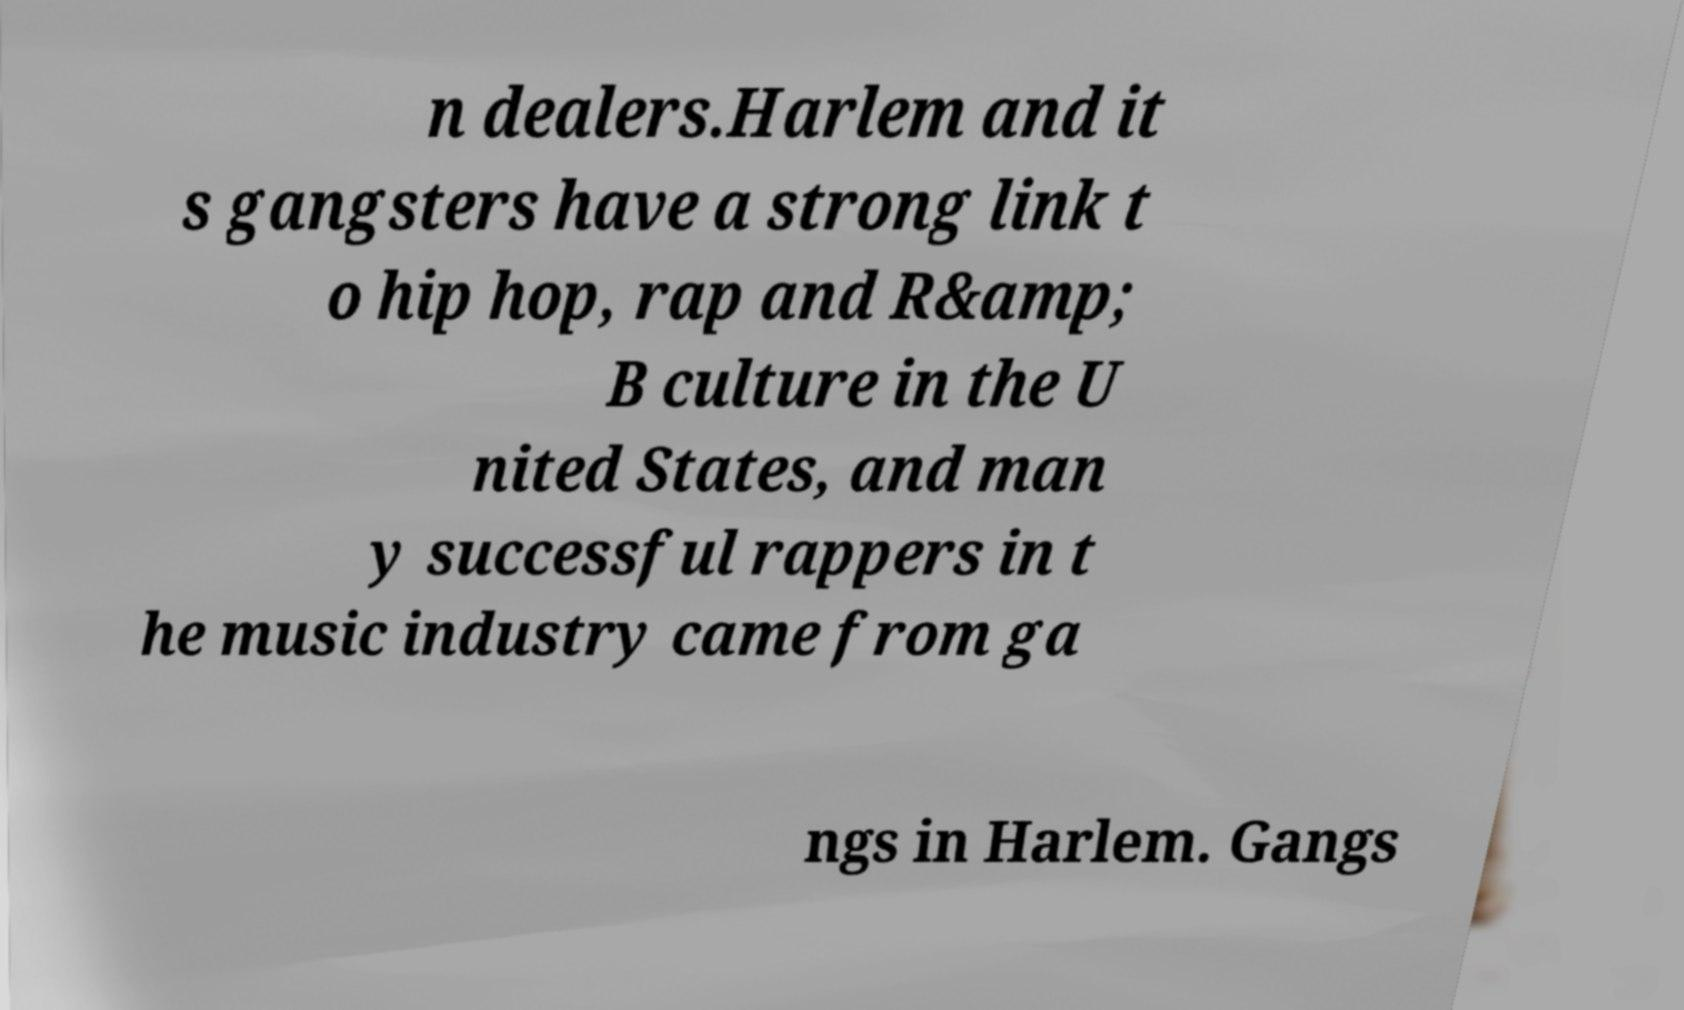What messages or text are displayed in this image? I need them in a readable, typed format. n dealers.Harlem and it s gangsters have a strong link t o hip hop, rap and R&amp; B culture in the U nited States, and man y successful rappers in t he music industry came from ga ngs in Harlem. Gangs 